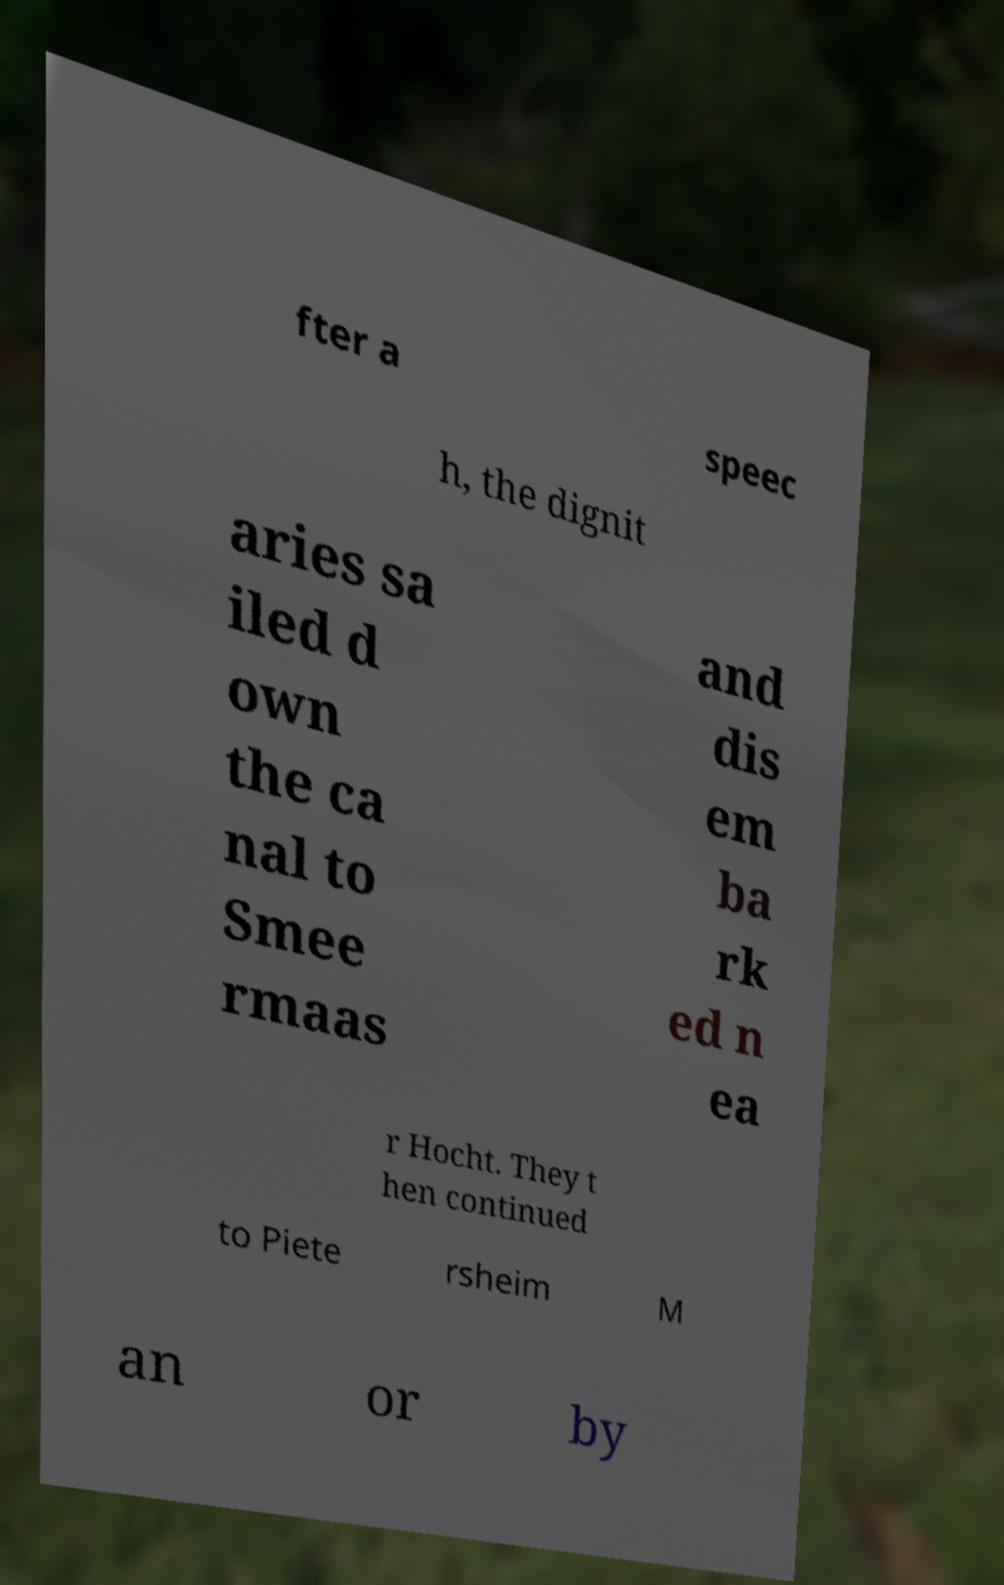Can you accurately transcribe the text from the provided image for me? fter a speec h, the dignit aries sa iled d own the ca nal to Smee rmaas and dis em ba rk ed n ea r Hocht. They t hen continued to Piete rsheim M an or by 